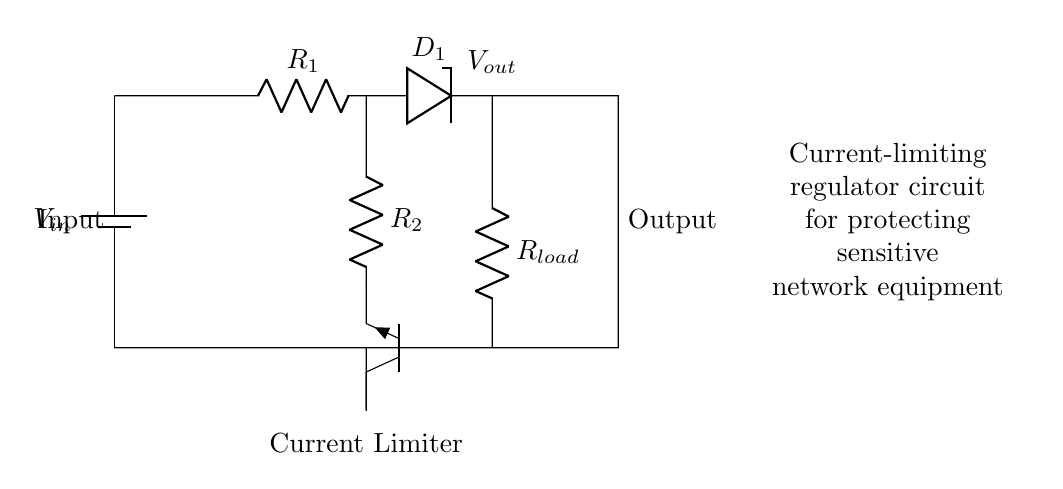What is the input voltage of the circuit? The circuit diagram indicates the input voltage as labeled with \( V_{in} \). This value is typically defined by the power supply connected at the top.
Answer: \( V_{in} \) What component limits the current in this regulator? In the circuit, the current limiter is explicitly mentioned as the "Current Limiter," which consists of the resistor \( R_2 \) and the transistor \( Q1 \) connected to it. This combination serves to restrict the amount of current that can pass, protecting sensitive components downstream.
Answer: Current Limiter What is the load resistor labeled in the circuit? The circuit diagram shows a resistor labeled \( R_{load} \) situated between \( D_1 \) and ground, which represents the load that the regulator is supplying. This resistor is crucial as it indicates what the regulator is supplying power to.
Answer: \( R_{load} \) How many resistors are present in this regulator circuit? By examining the circuit diagram, we can see that there are two resistors labeled \( R_1 \) and \( R_2 \). Therefore, counting these components gives us a total of two resistors in the circuit.
Answer: Two What role does the diode \( D_1 \) play in this circuit? The diode \( D_1 \) ensures that the current flows in the correct direction and protects the circuit from potential reverse voltage that could damage sensitive components downstream. Its placement indicates it is part of the regulation mechanism.
Answer: Current direction control What is the output voltage from this regulation circuit? The output voltage labeled \( V_{out} \) is positioned beneath the load resistor \( R_{load} \). This voltage is the regulated voltage supplied to the load, indicative of how the circuit modifies the input voltage for safe distribution.
Answer: \( V_{out} \) 